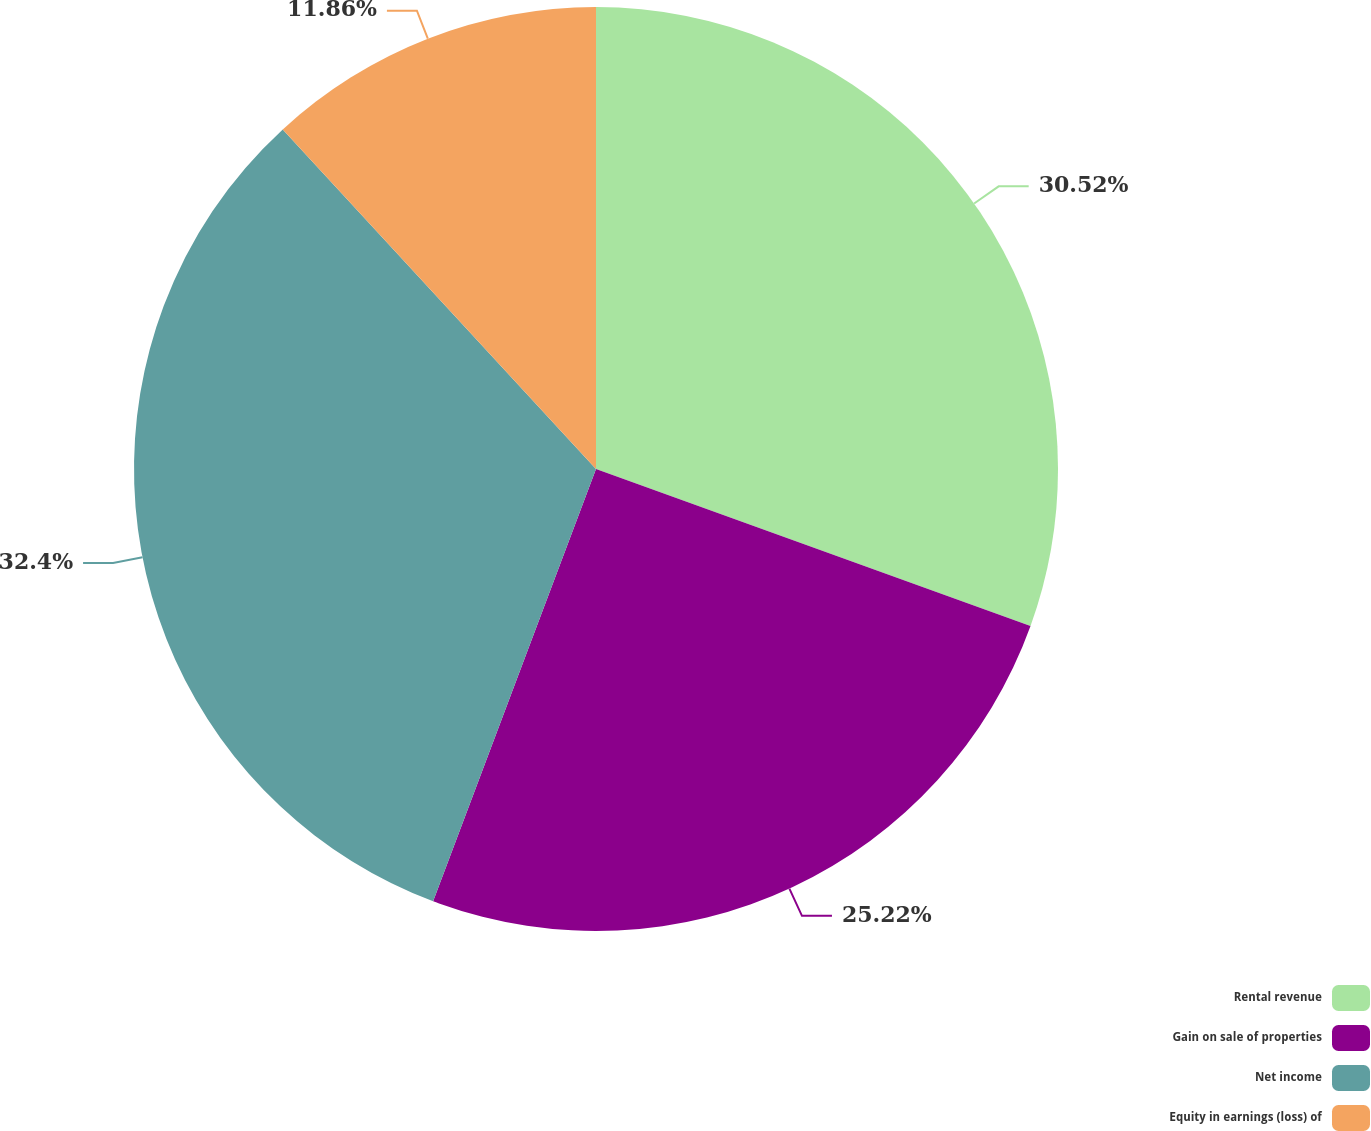<chart> <loc_0><loc_0><loc_500><loc_500><pie_chart><fcel>Rental revenue<fcel>Gain on sale of properties<fcel>Net income<fcel>Equity in earnings (loss) of<nl><fcel>30.52%<fcel>25.22%<fcel>32.41%<fcel>11.86%<nl></chart> 